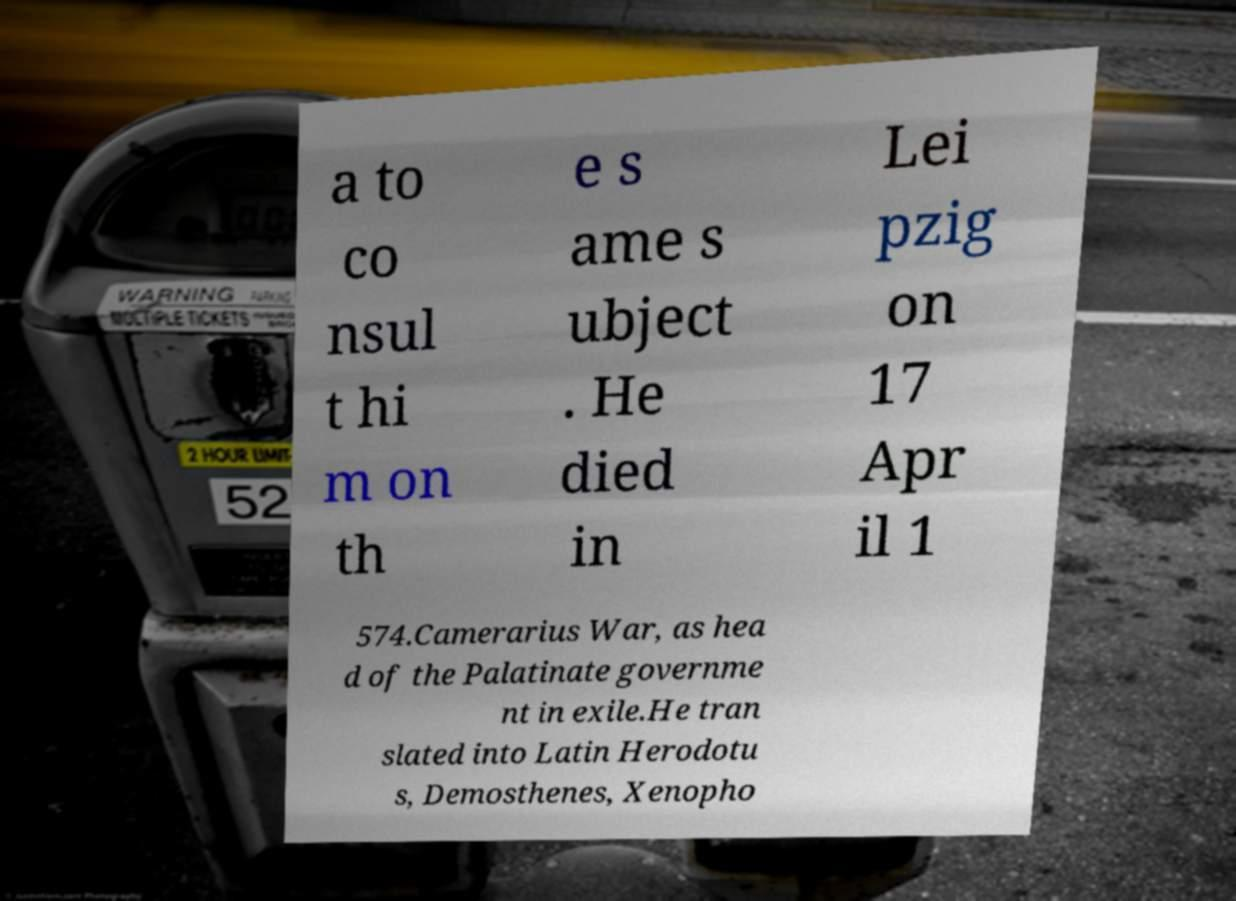Could you assist in decoding the text presented in this image and type it out clearly? a to co nsul t hi m on th e s ame s ubject . He died in Lei pzig on 17 Apr il 1 574.Camerarius War, as hea d of the Palatinate governme nt in exile.He tran slated into Latin Herodotu s, Demosthenes, Xenopho 